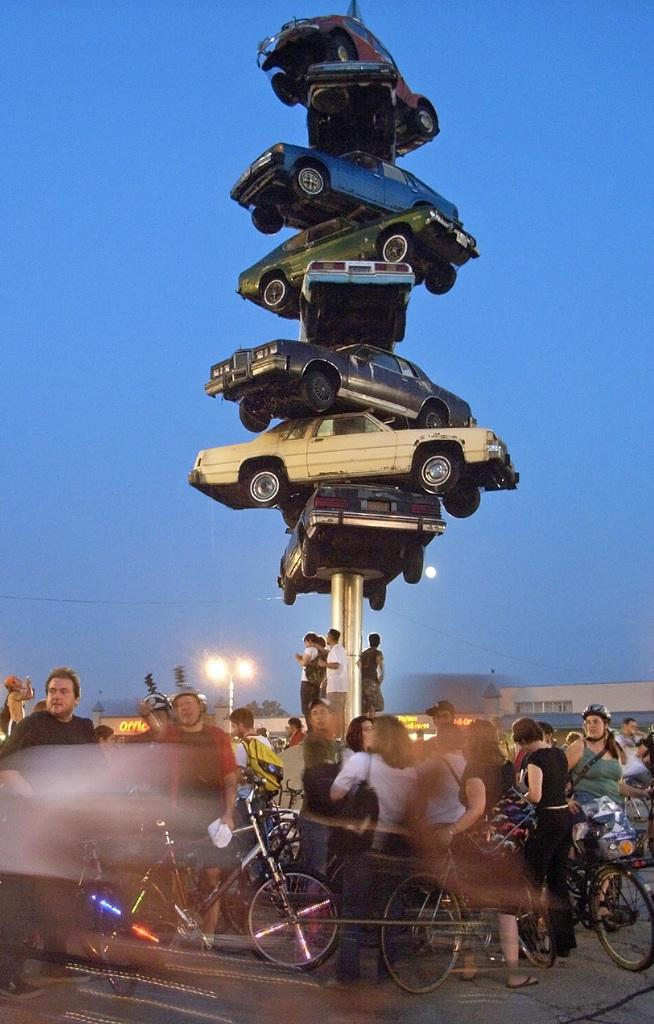What object can be seen in the image that is related to spinning or winding? There is a spindle in the image. What activity are the people engaged in, as depicted in the image? People are holding bicycles in the image. What type of lighting fixture is present in the image? There is a street light in the image. What type of structures can be seen in the background of the image? Houses are visible in the image. What type of plant is present in the image? There is a tree in the image. What is visible at the top of the image? The sky is visible at the top of the image. How does the self-driving car navigate the curve in the image? There is no self-driving car or curve present in the image. What type of vacation is being depicted in the image? The image does not depict a vacation; it shows people holding bicycles, a spindle, a street light, houses, a tree, and the sky. 